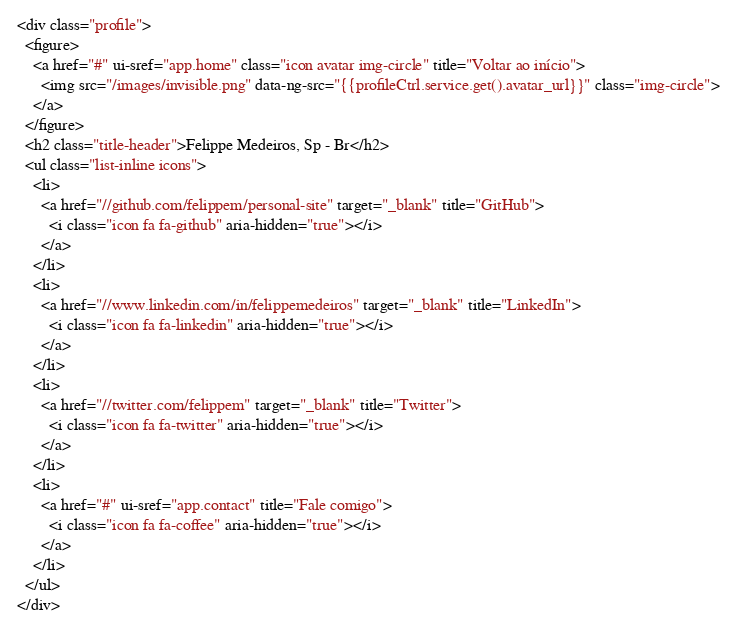<code> <loc_0><loc_0><loc_500><loc_500><_HTML_><div class="profile">
  <figure>
    <a href="#" ui-sref="app.home" class="icon avatar img-circle" title="Voltar ao início">
      <img src="/images/invisible.png" data-ng-src="{{profileCtrl.service.get().avatar_url}}" class="img-circle">
    </a>
  </figure>
  <h2 class="title-header">Felippe Medeiros, Sp - Br</h2>
  <ul class="list-inline icons">
    <li>
      <a href="//github.com/felippem/personal-site" target="_blank" title="GitHub">
        <i class="icon fa fa-github" aria-hidden="true"></i>
      </a>
    </li>
    <li>
      <a href="//www.linkedin.com/in/felippemedeiros" target="_blank" title="LinkedIn">
        <i class="icon fa fa-linkedin" aria-hidden="true"></i>
      </a>
    </li>
    <li>
      <a href="//twitter.com/felippem" target="_blank" title="Twitter">
        <i class="icon fa fa-twitter" aria-hidden="true"></i>
      </a>
    </li>
    <li>
      <a href="#" ui-sref="app.contact" title="Fale comigo">
        <i class="icon fa fa-coffee" aria-hidden="true"></i>
      </a>
    </li>
  </ul>
</div></code> 